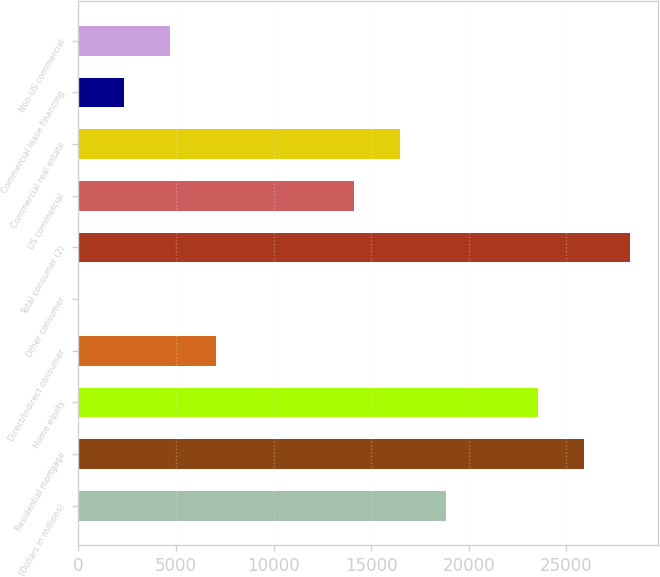Convert chart. <chart><loc_0><loc_0><loc_500><loc_500><bar_chart><fcel>(Dollars in millions)<fcel>Residential mortgage<fcel>Home equity<fcel>Direct/Indirect consumer<fcel>Other consumer<fcel>Total consumer (2)<fcel>US commercial<fcel>Commercial real estate<fcel>Commercial lease financing<fcel>Non-US commercial<nl><fcel>18844.4<fcel>25910.3<fcel>23555<fcel>7067.9<fcel>2<fcel>28265.6<fcel>14133.8<fcel>16489.1<fcel>2357.3<fcel>4712.6<nl></chart> 